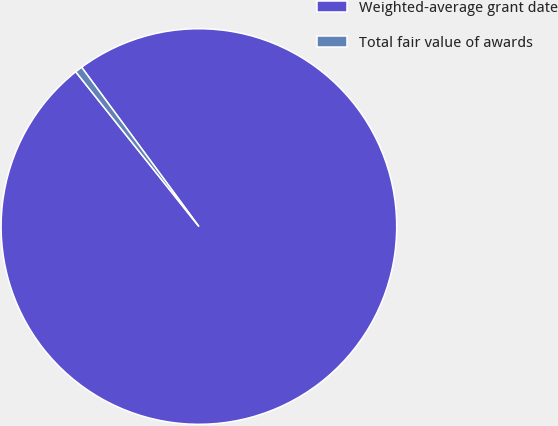Convert chart. <chart><loc_0><loc_0><loc_500><loc_500><pie_chart><fcel>Weighted-average grant date<fcel>Total fair value of awards<nl><fcel>99.4%<fcel>0.6%<nl></chart> 